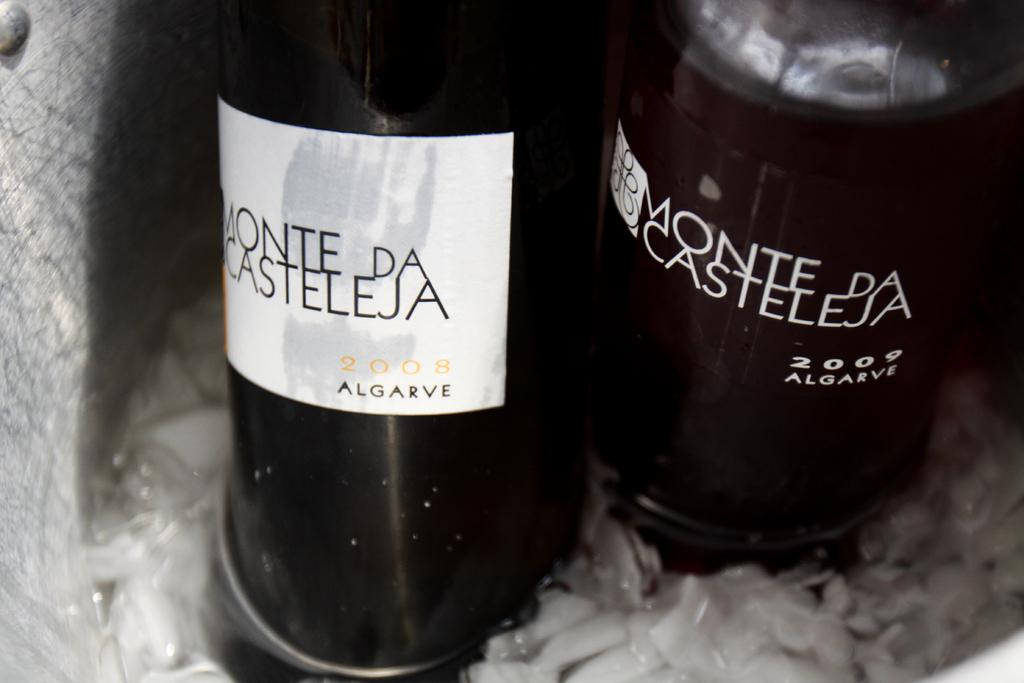<image>
Share a concise interpretation of the image provided. A can of Monte Da Casteleja Algarve 2008 is displayed next to one from 2009. 